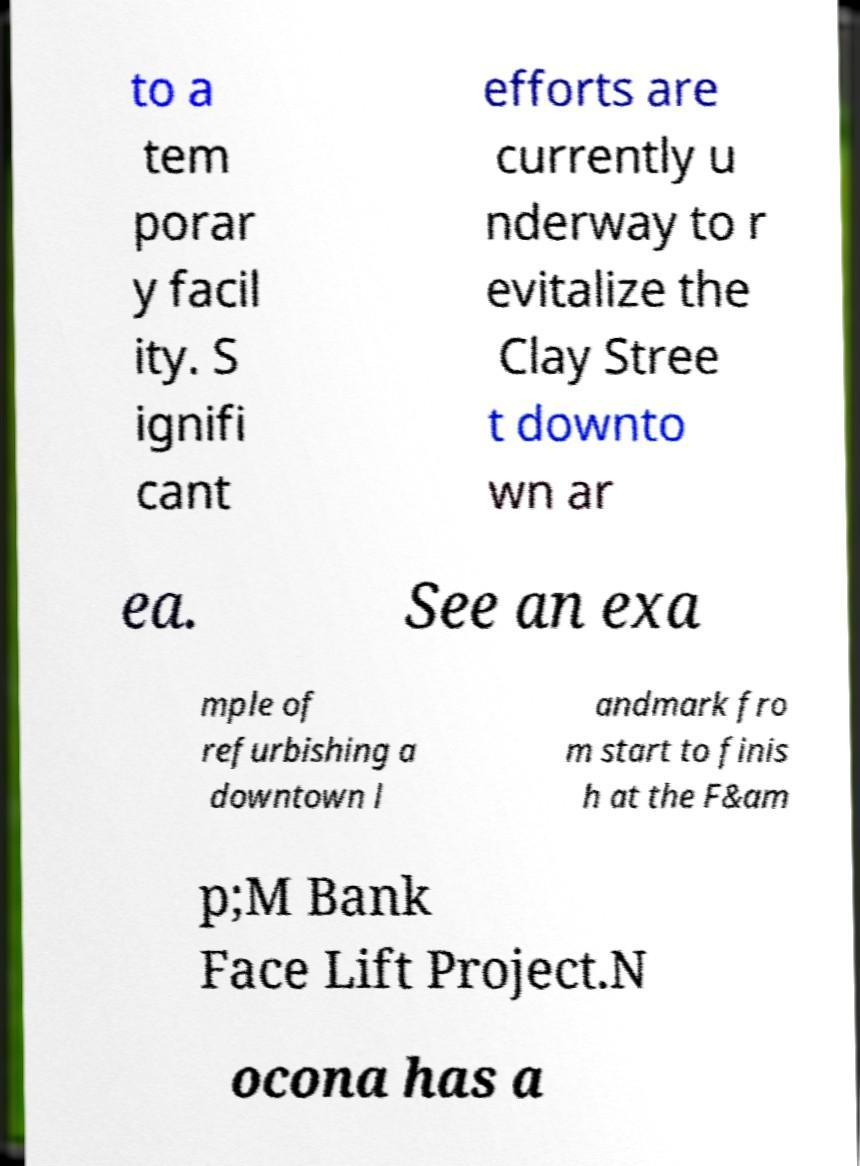Could you extract and type out the text from this image? to a tem porar y facil ity. S ignifi cant efforts are currently u nderway to r evitalize the Clay Stree t downto wn ar ea. See an exa mple of refurbishing a downtown l andmark fro m start to finis h at the F&am p;M Bank Face Lift Project.N ocona has a 